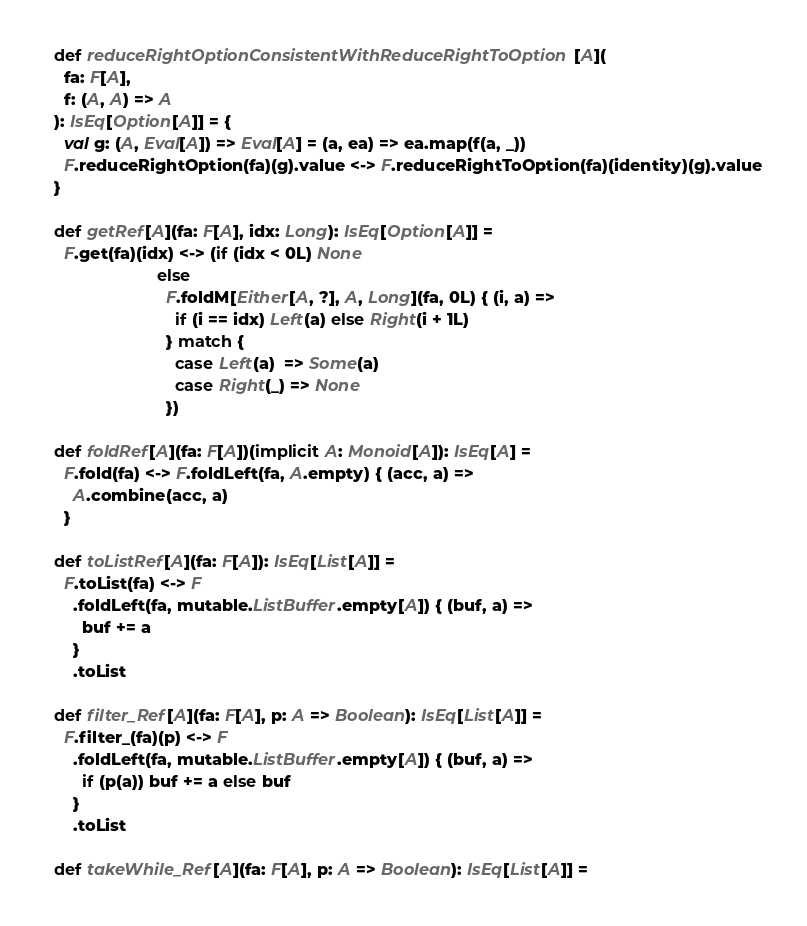Convert code to text. <code><loc_0><loc_0><loc_500><loc_500><_Scala_>  def reduceRightOptionConsistentWithReduceRightToOption[A](
    fa: F[A],
    f: (A, A) => A
  ): IsEq[Option[A]] = {
    val g: (A, Eval[A]) => Eval[A] = (a, ea) => ea.map(f(a, _))
    F.reduceRightOption(fa)(g).value <-> F.reduceRightToOption(fa)(identity)(g).value
  }

  def getRef[A](fa: F[A], idx: Long): IsEq[Option[A]] =
    F.get(fa)(idx) <-> (if (idx < 0L) None
                        else
                          F.foldM[Either[A, ?], A, Long](fa, 0L) { (i, a) =>
                            if (i == idx) Left(a) else Right(i + 1L)
                          } match {
                            case Left(a)  => Some(a)
                            case Right(_) => None
                          })

  def foldRef[A](fa: F[A])(implicit A: Monoid[A]): IsEq[A] =
    F.fold(fa) <-> F.foldLeft(fa, A.empty) { (acc, a) =>
      A.combine(acc, a)
    }

  def toListRef[A](fa: F[A]): IsEq[List[A]] =
    F.toList(fa) <-> F
      .foldLeft(fa, mutable.ListBuffer.empty[A]) { (buf, a) =>
        buf += a
      }
      .toList

  def filter_Ref[A](fa: F[A], p: A => Boolean): IsEq[List[A]] =
    F.filter_(fa)(p) <-> F
      .foldLeft(fa, mutable.ListBuffer.empty[A]) { (buf, a) =>
        if (p(a)) buf += a else buf
      }
      .toList

  def takeWhile_Ref[A](fa: F[A], p: A => Boolean): IsEq[List[A]] =</code> 